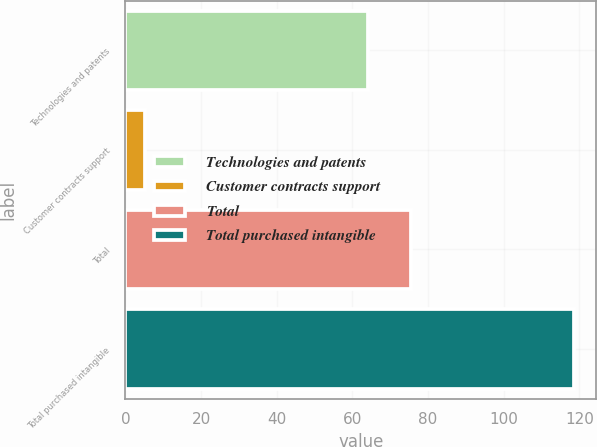<chart> <loc_0><loc_0><loc_500><loc_500><bar_chart><fcel>Technologies and patents<fcel>Customer contracts support<fcel>Total<fcel>Total purchased intangible<nl><fcel>64.2<fcel>5.3<fcel>75.52<fcel>118.5<nl></chart> 